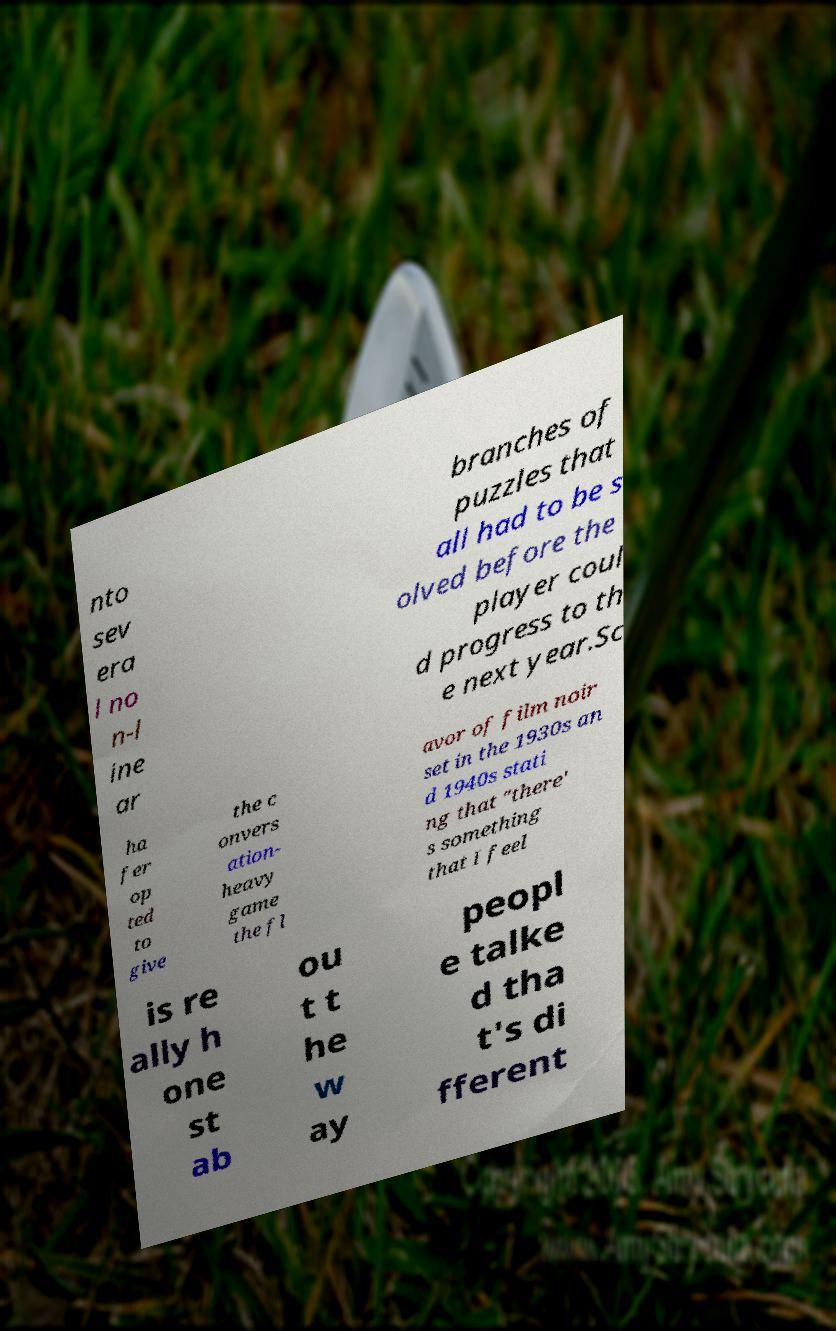I need the written content from this picture converted into text. Can you do that? nto sev era l no n-l ine ar branches of puzzles that all had to be s olved before the player coul d progress to th e next year.Sc ha fer op ted to give the c onvers ation- heavy game the fl avor of film noir set in the 1930s an d 1940s stati ng that "there' s something that I feel is re ally h one st ab ou t t he w ay peopl e talke d tha t's di fferent 